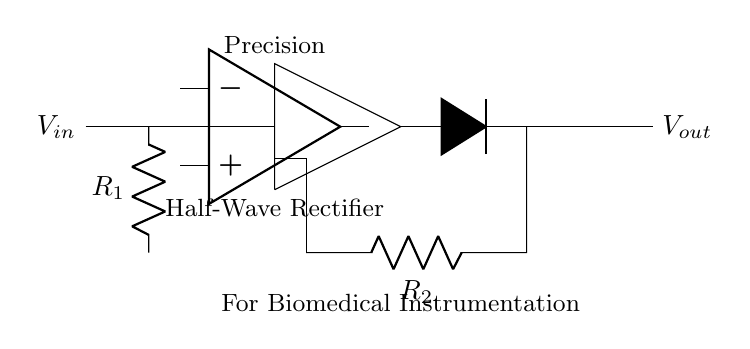What type of circuit is depicted? The circuit is a precision half-wave rectifier, as indicated by the labeling near the op-amp and the configuration of components.
Answer: precision half-wave rectifier What component is used for rectification? The diode, represented as D*, is used for rectification, allowing current to flow in only one direction.
Answer: diode How many resistors are in the circuit? There are two resistors labeled R_1 and R_2, which are critical for setting the gain and load in the circuit.
Answer: two What is the purpose of the op-amp in this circuit? The op-amp functions to amplify the input signal and ensures precision in the rectification process by controlling the output voltage.
Answer: amplification What is the expected output voltage type of this circuit? The output voltage is a pulsed DC signal, which corresponds to the positive cycles of the input AC signal while blocking the negative cycles.
Answer: pulsed DC How does the feedback loop affect the output? The feedback loop is connected through R_2 and helps stabilize the output voltage by providing negative feedback, which improves linearity and accuracy.
Answer: stabilizes output What is the application of this rectifier circuit? This precision half-wave rectifier is specifically designed for biomedical instrumentation, which requires high accuracy and fidelity in signal processing.
Answer: biomedical instrumentation 